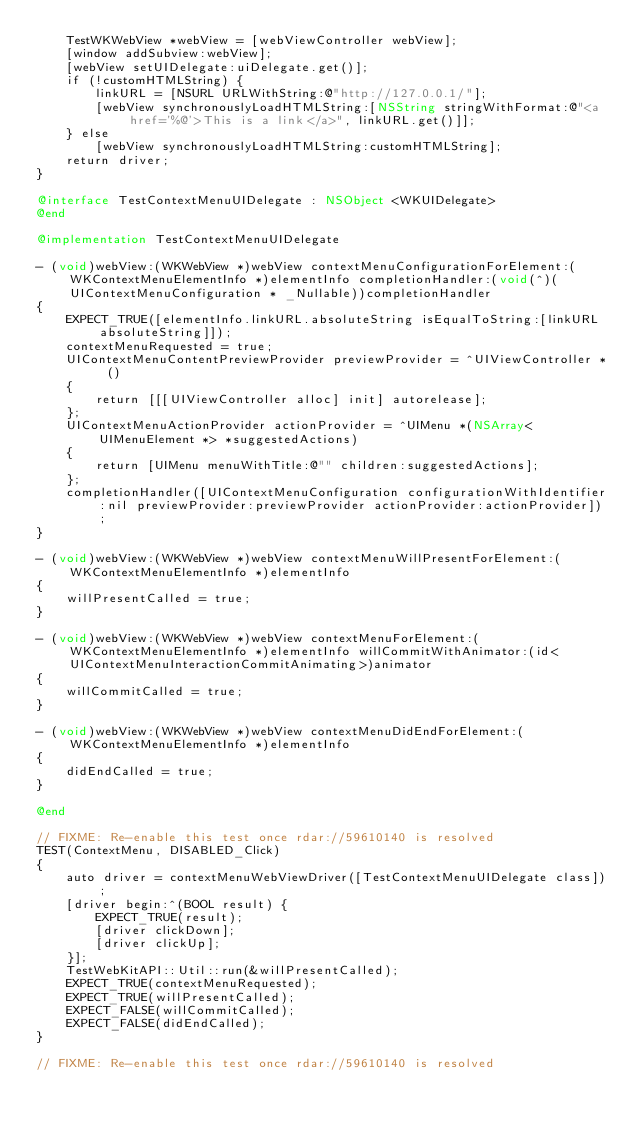Convert code to text. <code><loc_0><loc_0><loc_500><loc_500><_ObjectiveC_>    TestWKWebView *webView = [webViewController webView];
    [window addSubview:webView];
    [webView setUIDelegate:uiDelegate.get()];
    if (!customHTMLString) {
        linkURL = [NSURL URLWithString:@"http://127.0.0.1/"];
        [webView synchronouslyLoadHTMLString:[NSString stringWithFormat:@"<a href='%@'>This is a link</a>", linkURL.get()]];
    } else
        [webView synchronouslyLoadHTMLString:customHTMLString];
    return driver;
}

@interface TestContextMenuUIDelegate : NSObject <WKUIDelegate>
@end

@implementation TestContextMenuUIDelegate

- (void)webView:(WKWebView *)webView contextMenuConfigurationForElement:(WKContextMenuElementInfo *)elementInfo completionHandler:(void(^)(UIContextMenuConfiguration * _Nullable))completionHandler
{
    EXPECT_TRUE([elementInfo.linkURL.absoluteString isEqualToString:[linkURL absoluteString]]);
    contextMenuRequested = true;
    UIContextMenuContentPreviewProvider previewProvider = ^UIViewController * ()
    {
        return [[[UIViewController alloc] init] autorelease];
    };
    UIContextMenuActionProvider actionProvider = ^UIMenu *(NSArray<UIMenuElement *> *suggestedActions)
    {
        return [UIMenu menuWithTitle:@"" children:suggestedActions];
    };
    completionHandler([UIContextMenuConfiguration configurationWithIdentifier:nil previewProvider:previewProvider actionProvider:actionProvider]);
}

- (void)webView:(WKWebView *)webView contextMenuWillPresentForElement:(WKContextMenuElementInfo *)elementInfo
{
    willPresentCalled = true;
}

- (void)webView:(WKWebView *)webView contextMenuForElement:(WKContextMenuElementInfo *)elementInfo willCommitWithAnimator:(id<UIContextMenuInteractionCommitAnimating>)animator
{
    willCommitCalled = true;
}

- (void)webView:(WKWebView *)webView contextMenuDidEndForElement:(WKContextMenuElementInfo *)elementInfo
{
    didEndCalled = true;
}

@end

// FIXME: Re-enable this test once rdar://59610140 is resolved
TEST(ContextMenu, DISABLED_Click)
{
    auto driver = contextMenuWebViewDriver([TestContextMenuUIDelegate class]);
    [driver begin:^(BOOL result) {
        EXPECT_TRUE(result);
        [driver clickDown];
        [driver clickUp];
    }];
    TestWebKitAPI::Util::run(&willPresentCalled);
    EXPECT_TRUE(contextMenuRequested);
    EXPECT_TRUE(willPresentCalled);
    EXPECT_FALSE(willCommitCalled);
    EXPECT_FALSE(didEndCalled);
}

// FIXME: Re-enable this test once rdar://59610140 is resolved</code> 